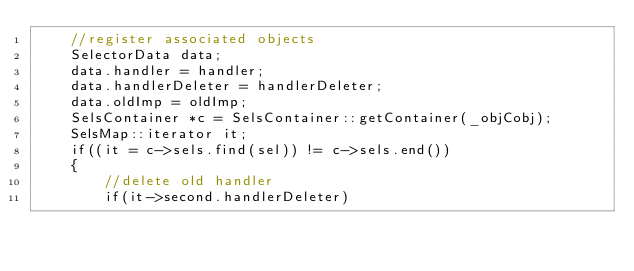<code> <loc_0><loc_0><loc_500><loc_500><_ObjectiveC_>    //register associated objects
    SelectorData data;
    data.handler = handler;
    data.handlerDeleter = handlerDeleter;
    data.oldImp = oldImp;
    SelsContainer *c = SelsContainer::getContainer(_objCobj);
    SelsMap::iterator it;
    if((it = c->sels.find(sel)) != c->sels.end())
    {
        //delete old handler
        if(it->second.handlerDeleter)</code> 